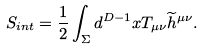Convert formula to latex. <formula><loc_0><loc_0><loc_500><loc_500>S _ { i n t } = \frac { 1 } { 2 } \int _ { \Sigma } d ^ { D - 1 } x T _ { \mu \nu } \widetilde { h } ^ { \mu \nu } .</formula> 